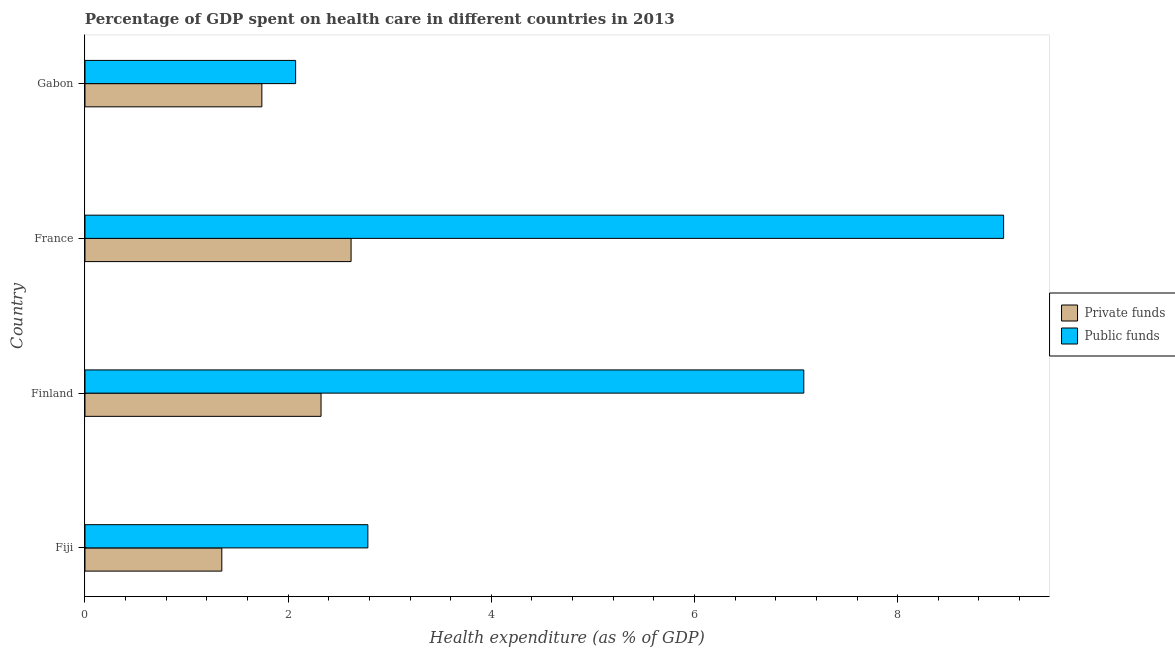How many different coloured bars are there?
Offer a terse response. 2. Are the number of bars per tick equal to the number of legend labels?
Your answer should be compact. Yes. Are the number of bars on each tick of the Y-axis equal?
Make the answer very short. Yes. How many bars are there on the 2nd tick from the top?
Offer a very short reply. 2. How many bars are there on the 2nd tick from the bottom?
Offer a very short reply. 2. What is the label of the 4th group of bars from the top?
Your answer should be compact. Fiji. In how many cases, is the number of bars for a given country not equal to the number of legend labels?
Ensure brevity in your answer.  0. What is the amount of private funds spent in healthcare in Fiji?
Provide a succinct answer. 1.35. Across all countries, what is the maximum amount of public funds spent in healthcare?
Ensure brevity in your answer.  9.04. Across all countries, what is the minimum amount of public funds spent in healthcare?
Your response must be concise. 2.07. In which country was the amount of public funds spent in healthcare minimum?
Provide a succinct answer. Gabon. What is the total amount of private funds spent in healthcare in the graph?
Offer a terse response. 8.03. What is the difference between the amount of public funds spent in healthcare in France and that in Gabon?
Provide a short and direct response. 6.97. What is the difference between the amount of private funds spent in healthcare in Fiji and the amount of public funds spent in healthcare in France?
Ensure brevity in your answer.  -7.7. What is the average amount of private funds spent in healthcare per country?
Provide a succinct answer. 2.01. What is the difference between the amount of public funds spent in healthcare and amount of private funds spent in healthcare in Gabon?
Keep it short and to the point. 0.33. In how many countries, is the amount of private funds spent in healthcare greater than 2.8 %?
Ensure brevity in your answer.  0. What is the ratio of the amount of private funds spent in healthcare in Finland to that in France?
Keep it short and to the point. 0.89. Is the amount of public funds spent in healthcare in France less than that in Gabon?
Your response must be concise. No. Is the difference between the amount of public funds spent in healthcare in Finland and Gabon greater than the difference between the amount of private funds spent in healthcare in Finland and Gabon?
Ensure brevity in your answer.  Yes. What is the difference between the highest and the second highest amount of private funds spent in healthcare?
Ensure brevity in your answer.  0.3. What is the difference between the highest and the lowest amount of private funds spent in healthcare?
Provide a succinct answer. 1.27. In how many countries, is the amount of private funds spent in healthcare greater than the average amount of private funds spent in healthcare taken over all countries?
Make the answer very short. 2. Is the sum of the amount of private funds spent in healthcare in Finland and Gabon greater than the maximum amount of public funds spent in healthcare across all countries?
Your answer should be very brief. No. What does the 1st bar from the top in Gabon represents?
Make the answer very short. Public funds. What does the 2nd bar from the bottom in France represents?
Provide a short and direct response. Public funds. Are all the bars in the graph horizontal?
Provide a short and direct response. Yes. How many countries are there in the graph?
Offer a very short reply. 4. What is the difference between two consecutive major ticks on the X-axis?
Give a very brief answer. 2. Are the values on the major ticks of X-axis written in scientific E-notation?
Your response must be concise. No. Does the graph contain any zero values?
Provide a short and direct response. No. Where does the legend appear in the graph?
Give a very brief answer. Center right. What is the title of the graph?
Keep it short and to the point. Percentage of GDP spent on health care in different countries in 2013. Does "Taxes" appear as one of the legend labels in the graph?
Offer a very short reply. No. What is the label or title of the X-axis?
Make the answer very short. Health expenditure (as % of GDP). What is the label or title of the Y-axis?
Your answer should be compact. Country. What is the Health expenditure (as % of GDP) in Private funds in Fiji?
Make the answer very short. 1.35. What is the Health expenditure (as % of GDP) in Public funds in Fiji?
Your response must be concise. 2.78. What is the Health expenditure (as % of GDP) of Private funds in Finland?
Ensure brevity in your answer.  2.32. What is the Health expenditure (as % of GDP) of Public funds in Finland?
Your answer should be compact. 7.08. What is the Health expenditure (as % of GDP) of Private funds in France?
Give a very brief answer. 2.62. What is the Health expenditure (as % of GDP) of Public funds in France?
Your answer should be compact. 9.04. What is the Health expenditure (as % of GDP) in Private funds in Gabon?
Your answer should be compact. 1.74. What is the Health expenditure (as % of GDP) in Public funds in Gabon?
Offer a terse response. 2.07. Across all countries, what is the maximum Health expenditure (as % of GDP) in Private funds?
Provide a succinct answer. 2.62. Across all countries, what is the maximum Health expenditure (as % of GDP) in Public funds?
Keep it short and to the point. 9.04. Across all countries, what is the minimum Health expenditure (as % of GDP) of Private funds?
Ensure brevity in your answer.  1.35. Across all countries, what is the minimum Health expenditure (as % of GDP) of Public funds?
Ensure brevity in your answer.  2.07. What is the total Health expenditure (as % of GDP) of Private funds in the graph?
Give a very brief answer. 8.03. What is the total Health expenditure (as % of GDP) in Public funds in the graph?
Offer a very short reply. 20.98. What is the difference between the Health expenditure (as % of GDP) in Private funds in Fiji and that in Finland?
Your response must be concise. -0.98. What is the difference between the Health expenditure (as % of GDP) of Public funds in Fiji and that in Finland?
Offer a very short reply. -4.29. What is the difference between the Health expenditure (as % of GDP) in Private funds in Fiji and that in France?
Keep it short and to the point. -1.27. What is the difference between the Health expenditure (as % of GDP) in Public funds in Fiji and that in France?
Give a very brief answer. -6.26. What is the difference between the Health expenditure (as % of GDP) in Private funds in Fiji and that in Gabon?
Provide a succinct answer. -0.39. What is the difference between the Health expenditure (as % of GDP) in Public funds in Fiji and that in Gabon?
Ensure brevity in your answer.  0.71. What is the difference between the Health expenditure (as % of GDP) in Private funds in Finland and that in France?
Offer a very short reply. -0.3. What is the difference between the Health expenditure (as % of GDP) of Public funds in Finland and that in France?
Ensure brevity in your answer.  -1.97. What is the difference between the Health expenditure (as % of GDP) in Private funds in Finland and that in Gabon?
Your response must be concise. 0.58. What is the difference between the Health expenditure (as % of GDP) of Public funds in Finland and that in Gabon?
Offer a terse response. 5. What is the difference between the Health expenditure (as % of GDP) of Private funds in France and that in Gabon?
Make the answer very short. 0.88. What is the difference between the Health expenditure (as % of GDP) in Public funds in France and that in Gabon?
Make the answer very short. 6.97. What is the difference between the Health expenditure (as % of GDP) of Private funds in Fiji and the Health expenditure (as % of GDP) of Public funds in Finland?
Your answer should be compact. -5.73. What is the difference between the Health expenditure (as % of GDP) in Private funds in Fiji and the Health expenditure (as % of GDP) in Public funds in France?
Keep it short and to the point. -7.7. What is the difference between the Health expenditure (as % of GDP) of Private funds in Fiji and the Health expenditure (as % of GDP) of Public funds in Gabon?
Your response must be concise. -0.73. What is the difference between the Health expenditure (as % of GDP) of Private funds in Finland and the Health expenditure (as % of GDP) of Public funds in France?
Your answer should be very brief. -6.72. What is the difference between the Health expenditure (as % of GDP) of Private funds in Finland and the Health expenditure (as % of GDP) of Public funds in Gabon?
Give a very brief answer. 0.25. What is the difference between the Health expenditure (as % of GDP) of Private funds in France and the Health expenditure (as % of GDP) of Public funds in Gabon?
Your answer should be very brief. 0.55. What is the average Health expenditure (as % of GDP) of Private funds per country?
Provide a short and direct response. 2.01. What is the average Health expenditure (as % of GDP) of Public funds per country?
Offer a terse response. 5.24. What is the difference between the Health expenditure (as % of GDP) in Private funds and Health expenditure (as % of GDP) in Public funds in Fiji?
Provide a succinct answer. -1.44. What is the difference between the Health expenditure (as % of GDP) in Private funds and Health expenditure (as % of GDP) in Public funds in Finland?
Provide a succinct answer. -4.75. What is the difference between the Health expenditure (as % of GDP) in Private funds and Health expenditure (as % of GDP) in Public funds in France?
Give a very brief answer. -6.42. What is the difference between the Health expenditure (as % of GDP) in Private funds and Health expenditure (as % of GDP) in Public funds in Gabon?
Your answer should be very brief. -0.33. What is the ratio of the Health expenditure (as % of GDP) in Private funds in Fiji to that in Finland?
Provide a succinct answer. 0.58. What is the ratio of the Health expenditure (as % of GDP) in Public funds in Fiji to that in Finland?
Your response must be concise. 0.39. What is the ratio of the Health expenditure (as % of GDP) in Private funds in Fiji to that in France?
Offer a very short reply. 0.51. What is the ratio of the Health expenditure (as % of GDP) of Public funds in Fiji to that in France?
Ensure brevity in your answer.  0.31. What is the ratio of the Health expenditure (as % of GDP) of Private funds in Fiji to that in Gabon?
Offer a very short reply. 0.77. What is the ratio of the Health expenditure (as % of GDP) of Public funds in Fiji to that in Gabon?
Offer a very short reply. 1.34. What is the ratio of the Health expenditure (as % of GDP) in Private funds in Finland to that in France?
Your answer should be compact. 0.89. What is the ratio of the Health expenditure (as % of GDP) in Public funds in Finland to that in France?
Your response must be concise. 0.78. What is the ratio of the Health expenditure (as % of GDP) of Private funds in Finland to that in Gabon?
Ensure brevity in your answer.  1.33. What is the ratio of the Health expenditure (as % of GDP) of Public funds in Finland to that in Gabon?
Provide a succinct answer. 3.41. What is the ratio of the Health expenditure (as % of GDP) of Private funds in France to that in Gabon?
Offer a terse response. 1.5. What is the ratio of the Health expenditure (as % of GDP) of Public funds in France to that in Gabon?
Your answer should be compact. 4.36. What is the difference between the highest and the second highest Health expenditure (as % of GDP) of Private funds?
Provide a short and direct response. 0.3. What is the difference between the highest and the second highest Health expenditure (as % of GDP) in Public funds?
Make the answer very short. 1.97. What is the difference between the highest and the lowest Health expenditure (as % of GDP) of Private funds?
Your answer should be very brief. 1.27. What is the difference between the highest and the lowest Health expenditure (as % of GDP) of Public funds?
Offer a terse response. 6.97. 